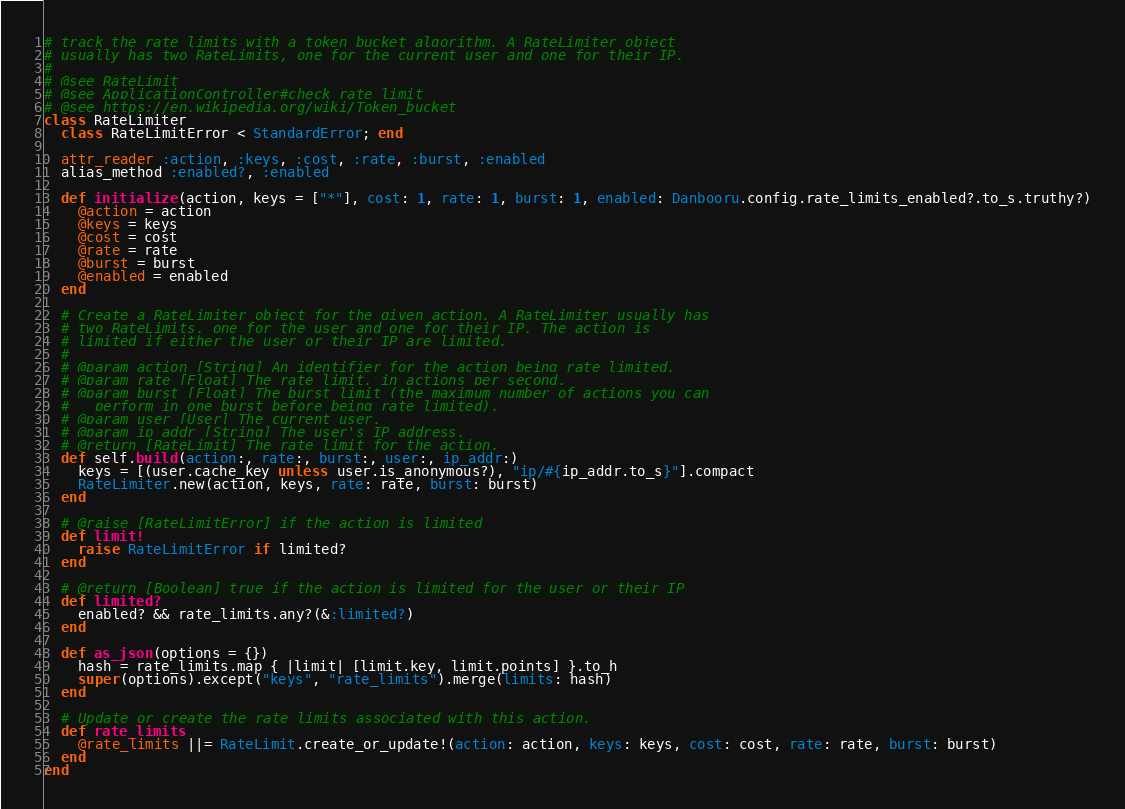<code> <loc_0><loc_0><loc_500><loc_500><_Ruby_># track the rate limits with a token bucket algorithm. A RateLimiter object
# usually has two RateLimits, one for the current user and one for their IP.
#
# @see RateLimit
# @see ApplicationController#check_rate_limit
# @see https://en.wikipedia.org/wiki/Token_bucket
class RateLimiter
  class RateLimitError < StandardError; end

  attr_reader :action, :keys, :cost, :rate, :burst, :enabled
  alias_method :enabled?, :enabled

  def initialize(action, keys = ["*"], cost: 1, rate: 1, burst: 1, enabled: Danbooru.config.rate_limits_enabled?.to_s.truthy?)
    @action = action
    @keys = keys
    @cost = cost
    @rate = rate
    @burst = burst
    @enabled = enabled
  end

  # Create a RateLimiter object for the given action. A RateLimiter usually has
  # two RateLimits, one for the user and one for their IP. The action is
  # limited if either the user or their IP are limited.
  #
  # @param action [String] An identifier for the action being rate limited.
  # @param rate [Float] The rate limit, in actions per second.
  # @param burst [Float] The burst limit (the maximum number of actions you can
  #   perform in one burst before being rate limited).
  # @param user [User] The current user.
  # @param ip_addr [String] The user's IP address.
  # @return [RateLimit] The rate limit for the action.
  def self.build(action:, rate:, burst:, user:, ip_addr:)
    keys = [(user.cache_key unless user.is_anonymous?), "ip/#{ip_addr.to_s}"].compact
    RateLimiter.new(action, keys, rate: rate, burst: burst)
  end

  # @raise [RateLimitError] if the action is limited
  def limit!
    raise RateLimitError if limited?
  end

  # @return [Boolean] true if the action is limited for the user or their IP
  def limited?
    enabled? && rate_limits.any?(&:limited?)
  end

  def as_json(options = {})
    hash = rate_limits.map { |limit| [limit.key, limit.points] }.to_h
    super(options).except("keys", "rate_limits").merge(limits: hash)
  end

  # Update or create the rate limits associated with this action.
  def rate_limits
    @rate_limits ||= RateLimit.create_or_update!(action: action, keys: keys, cost: cost, rate: rate, burst: burst)
  end
end
</code> 